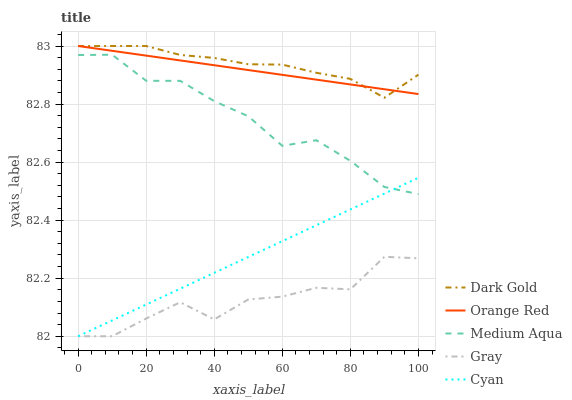Does Cyan have the minimum area under the curve?
Answer yes or no. No. Does Cyan have the maximum area under the curve?
Answer yes or no. No. Is Medium Aqua the smoothest?
Answer yes or no. No. Is Medium Aqua the roughest?
Answer yes or no. No. Does Medium Aqua have the lowest value?
Answer yes or no. No. Does Cyan have the highest value?
Answer yes or no. No. Is Medium Aqua less than Dark Gold?
Answer yes or no. Yes. Is Medium Aqua greater than Gray?
Answer yes or no. Yes. Does Medium Aqua intersect Dark Gold?
Answer yes or no. No. 